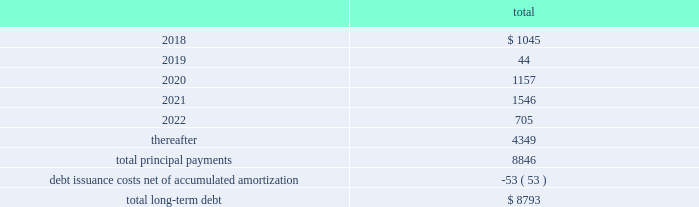Fidelity national information services , inc .
And subsidiaries notes to consolidated financial statements - ( continued ) the following summarizes the aggregate maturities of our debt and capital leases on stated contractual maturities , excluding unamortized non-cash bond premiums and discounts net of $ 30 million as of december 31 , 2017 ( in millions ) : .
There are no mandatory principal payments on the revolving loan and any balance outstanding on the revolving loan will be due and payable at its scheduled maturity date , which occurs at august 10 , 2021 .
Fis may redeem the 2018 notes , 2020 notes , 2021 notes , 2021 euro notes , 2022 notes , 2022 gbp notes , 2023 notes , 2024 notes , 2024 euro notes , 2025 notes , 2026 notes , and 2046 notes at its option in whole or in part , at any time and from time to time , at a redemption price equal to the greater of 100% ( 100 % ) of the principal amount to be redeemed and a make-whole amount calculated as described in the related indenture in each case plus accrued and unpaid interest to , but excluding , the date of redemption , provided no make-whole amount will be paid for redemptions of the 2020 notes , the 2021 notes , the 2021 euro notes and the 2022 gbp notes during the one month prior to their maturity , the 2022 notes during the two months prior to their maturity , the 2023 notes , the 2024 notes , the 2024 euro notes , the 2025 notes , and the 2026 notes during the three months prior to their maturity , and the 2046 notes during the six months prior to their maturity .
Debt issuance costs of $ 53 million , net of accumulated amortization , remain capitalized as of december 31 , 2017 , related to all of the above outstanding debt .
We monitor the financial stability of our counterparties on an ongoing basis .
The lender commitments under the undrawn portions of the revolving loan are comprised of a diversified set of financial institutions , both domestic and international .
The failure of any single lender to perform its obligations under the revolving loan would not adversely impact our ability to fund operations .
The fair value of the company 2019s long-term debt is estimated to be approximately $ 156 million higher than the carrying value as of december 31 , 2017 .
This estimate is based on quoted prices of our senior notes and trades of our other debt in close proximity to december 31 , 2017 , which are considered level 2-type measurements .
This estimate is subjective in nature and involves uncertainties and significant judgment in the interpretation of current market data .
Therefore , the values presented are not necessarily indicative of amounts the company could realize or settle currently. .
What portion of the total long-term debt is reported in the current liabilities section of the balance sheet as of december 31 , 2017? 
Computations: (1045 / 8793)
Answer: 0.11884. 